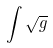Convert formula to latex. <formula><loc_0><loc_0><loc_500><loc_500>\int \sqrt { g }</formula> 